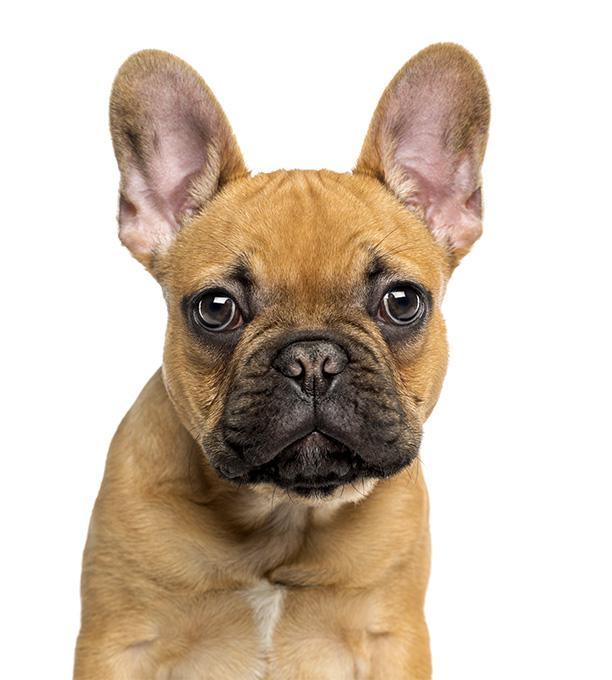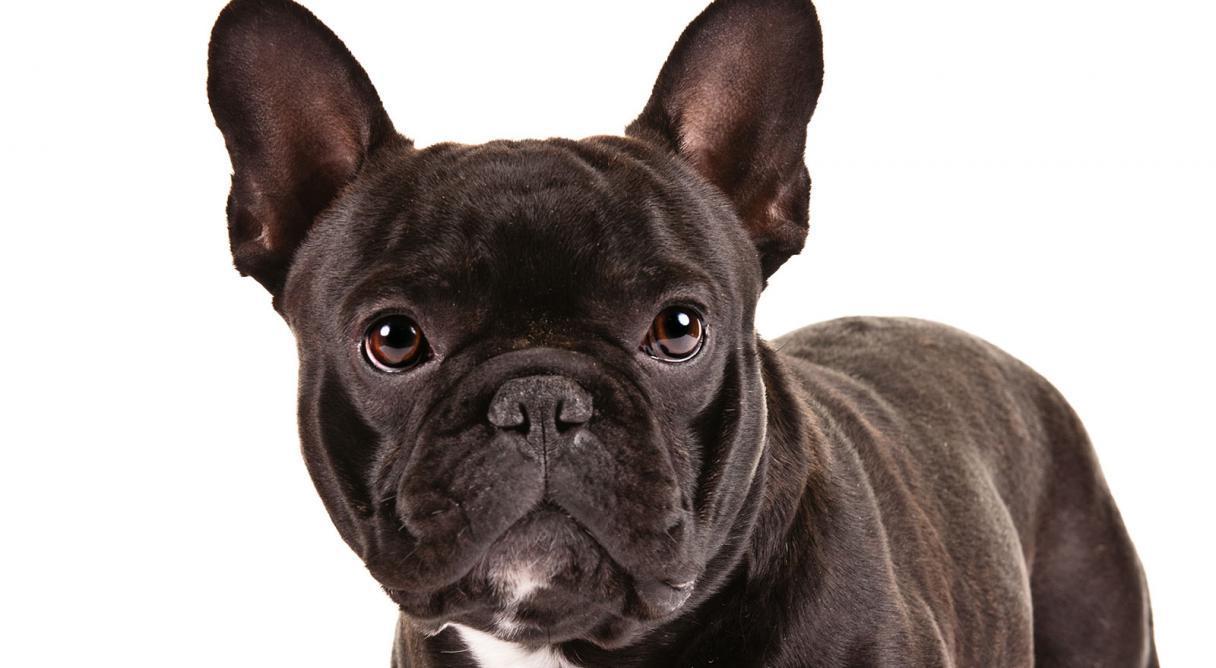The first image is the image on the left, the second image is the image on the right. Given the left and right images, does the statement "The dog in the image on the right is mostly black." hold true? Answer yes or no. Yes. 